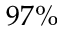<formula> <loc_0><loc_0><loc_500><loc_500>9 7 \%</formula> 